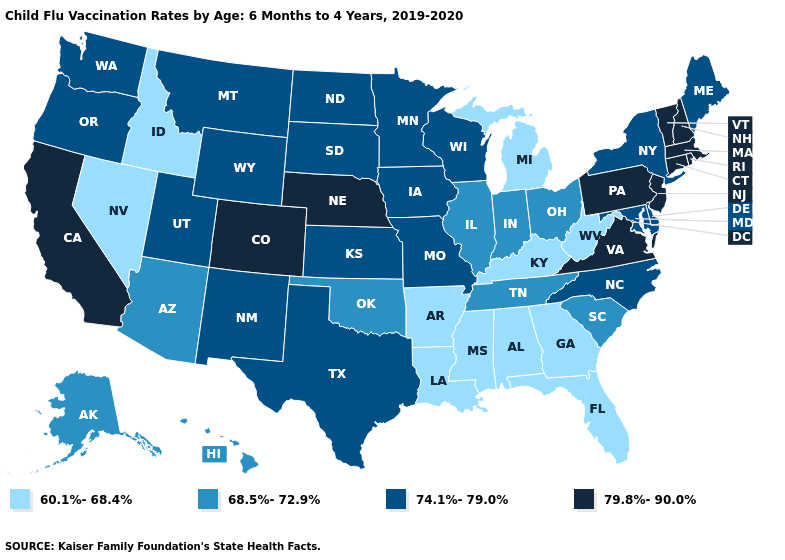What is the lowest value in states that border Pennsylvania?
Quick response, please. 60.1%-68.4%. Name the states that have a value in the range 68.5%-72.9%?
Give a very brief answer. Alaska, Arizona, Hawaii, Illinois, Indiana, Ohio, Oklahoma, South Carolina, Tennessee. What is the value of Delaware?
Answer briefly. 74.1%-79.0%. Does the map have missing data?
Write a very short answer. No. Which states have the lowest value in the USA?
Give a very brief answer. Alabama, Arkansas, Florida, Georgia, Idaho, Kentucky, Louisiana, Michigan, Mississippi, Nevada, West Virginia. Which states have the highest value in the USA?
Quick response, please. California, Colorado, Connecticut, Massachusetts, Nebraska, New Hampshire, New Jersey, Pennsylvania, Rhode Island, Vermont, Virginia. Does Florida have the lowest value in the South?
Concise answer only. Yes. What is the value of New Jersey?
Be succinct. 79.8%-90.0%. Name the states that have a value in the range 74.1%-79.0%?
Give a very brief answer. Delaware, Iowa, Kansas, Maine, Maryland, Minnesota, Missouri, Montana, New Mexico, New York, North Carolina, North Dakota, Oregon, South Dakota, Texas, Utah, Washington, Wisconsin, Wyoming. Which states hav the highest value in the West?
Quick response, please. California, Colorado. What is the highest value in the MidWest ?
Concise answer only. 79.8%-90.0%. What is the value of North Dakota?
Be succinct. 74.1%-79.0%. What is the highest value in the USA?
Keep it brief. 79.8%-90.0%. What is the lowest value in the Northeast?
Be succinct. 74.1%-79.0%. Which states have the lowest value in the USA?
Answer briefly. Alabama, Arkansas, Florida, Georgia, Idaho, Kentucky, Louisiana, Michigan, Mississippi, Nevada, West Virginia. 